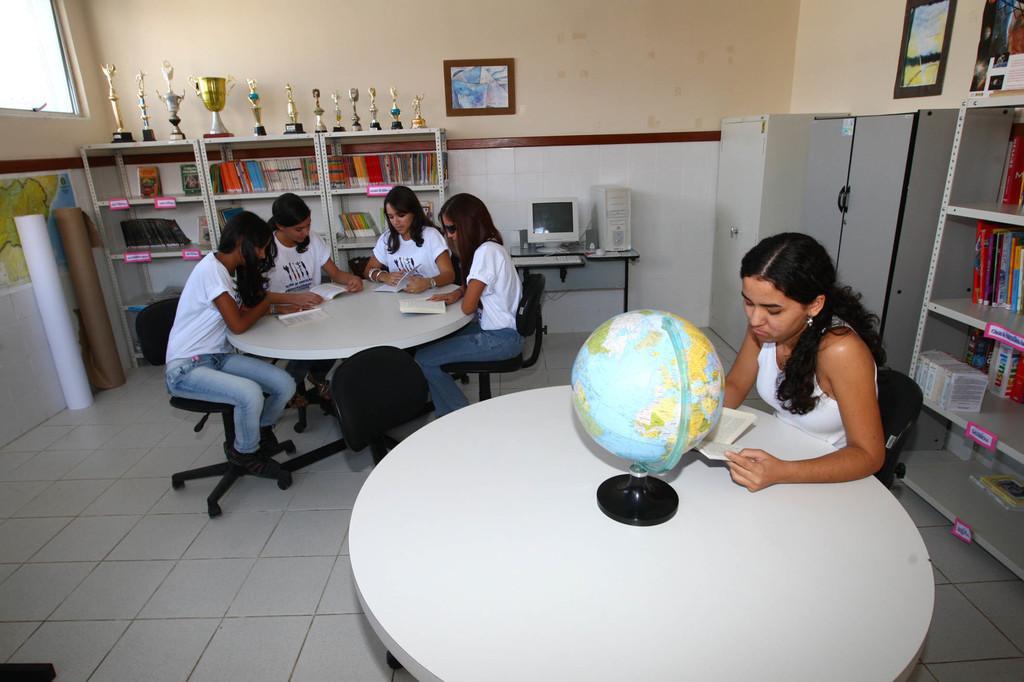How would you summarize this image in a sentence or two? This is a picture taken in a room, there are a group of people sitting on chairs in front of these people there is a table on the table there are books, globe, monitor and CPU. Behind the people there are shelves and lockers and in the lockers there are books on top of the lockers there are trophies. Background of the people is a wall with photos. 